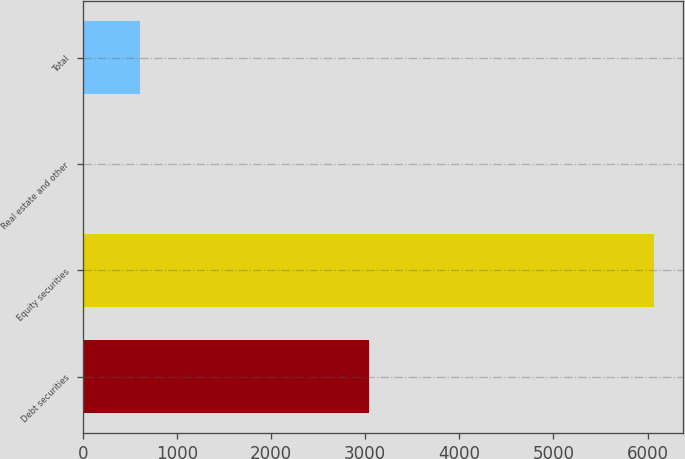Convert chart to OTSL. <chart><loc_0><loc_0><loc_500><loc_500><bar_chart><fcel>Debt securities<fcel>Equity securities<fcel>Real estate and other<fcel>Total<nl><fcel>3040<fcel>6070<fcel>5<fcel>611.5<nl></chart> 